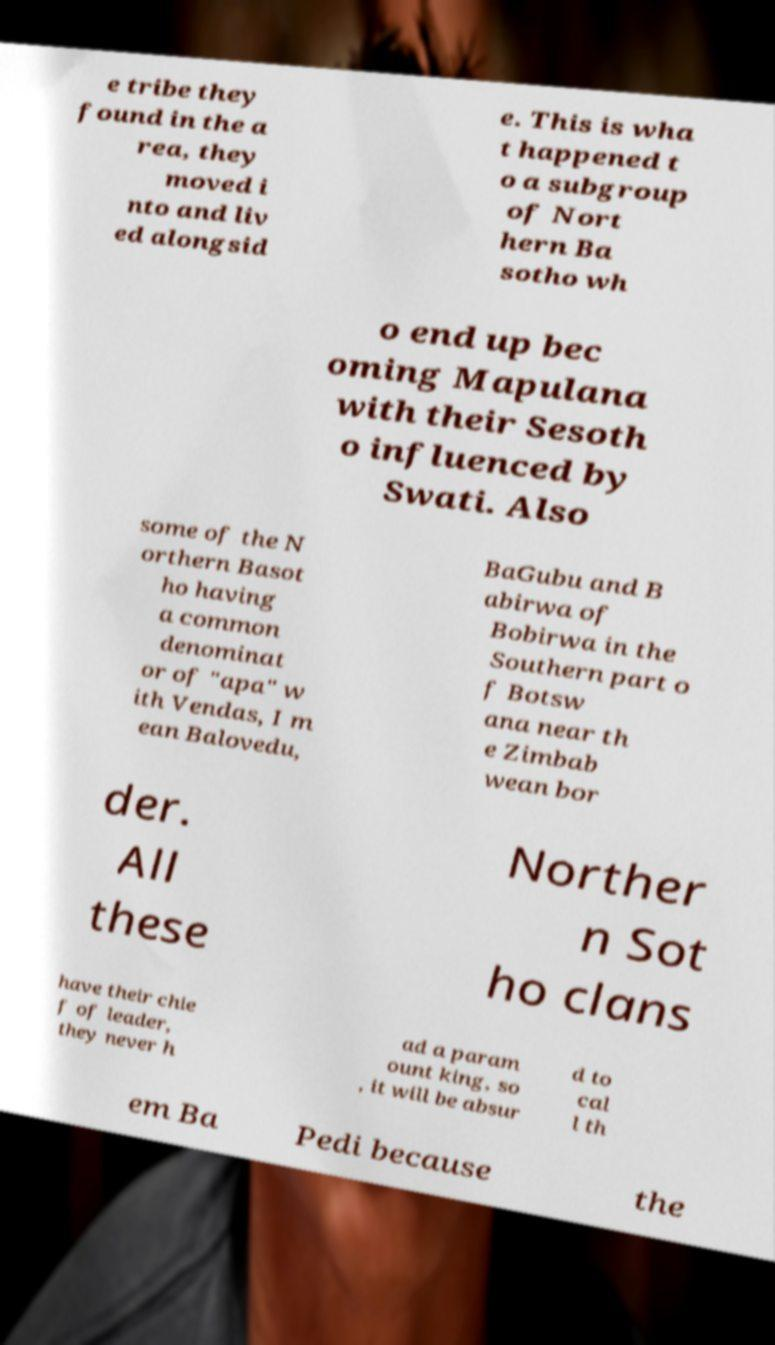Can you accurately transcribe the text from the provided image for me? e tribe they found in the a rea, they moved i nto and liv ed alongsid e. This is wha t happened t o a subgroup of Nort hern Ba sotho wh o end up bec oming Mapulana with their Sesoth o influenced by Swati. Also some of the N orthern Basot ho having a common denominat or of "apa" w ith Vendas, I m ean Balovedu, BaGubu and B abirwa of Bobirwa in the Southern part o f Botsw ana near th e Zimbab wean bor der. All these Norther n Sot ho clans have their chie f of leader, they never h ad a param ount king, so , it will be absur d to cal l th em Ba Pedi because the 